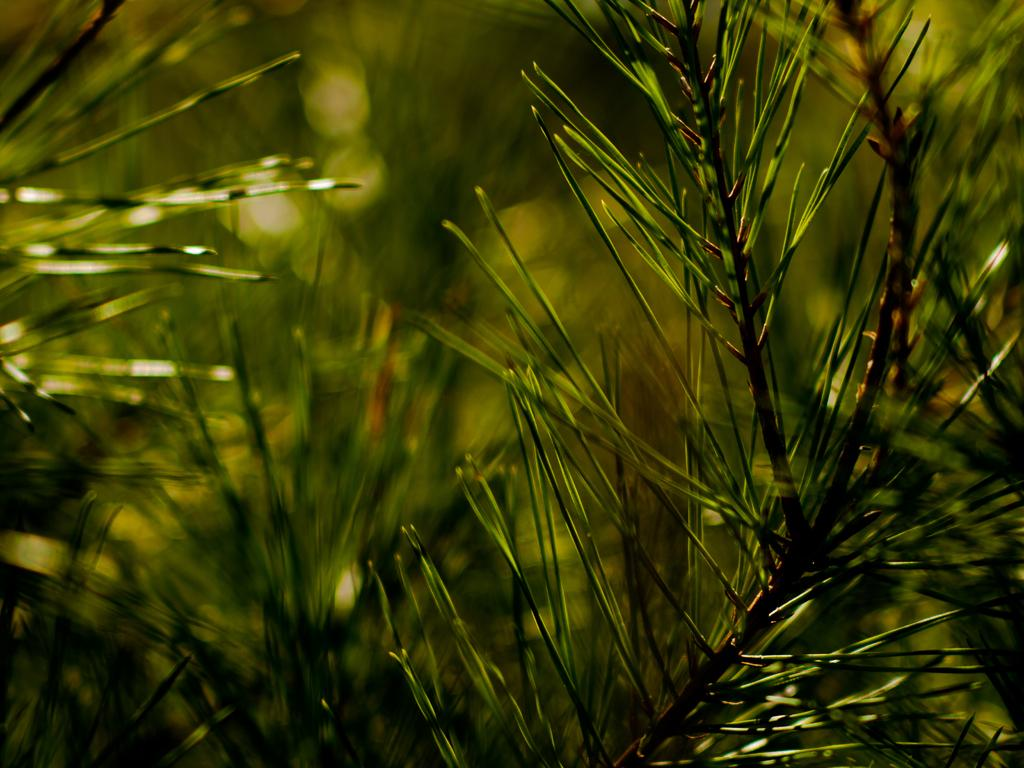What type of living organisms can be seen in the image? Plants can be seen in the image. What specific feature of the plants is mentioned in the facts? The plants do not have leaves. What type of porter is shown carrying a duck in the image? There is no porter or duck present in the image; it only features plants without leaves. How does the image convey a sense of hate or animosity? The image does not convey any sense of hate or animosity, as it only contains plants without leaves. 